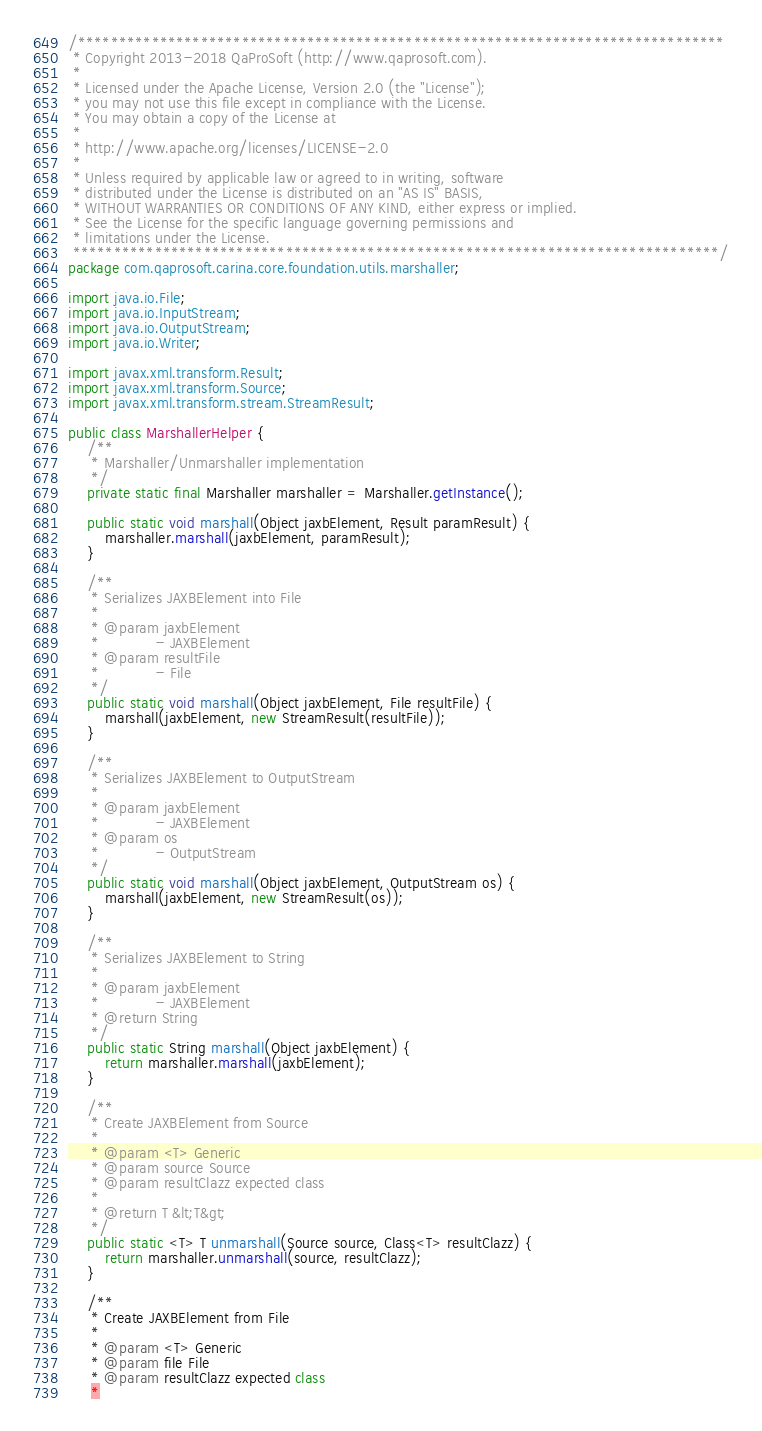Convert code to text. <code><loc_0><loc_0><loc_500><loc_500><_Java_>/*******************************************************************************
 * Copyright 2013-2018 QaProSoft (http://www.qaprosoft.com).
 *
 * Licensed under the Apache License, Version 2.0 (the "License");
 * you may not use this file except in compliance with the License.
 * You may obtain a copy of the License at
 *
 * http://www.apache.org/licenses/LICENSE-2.0
 *
 * Unless required by applicable law or agreed to in writing, software
 * distributed under the License is distributed on an "AS IS" BASIS,
 * WITHOUT WARRANTIES OR CONDITIONS OF ANY KIND, either express or implied.
 * See the License for the specific language governing permissions and
 * limitations under the License.
 *******************************************************************************/
package com.qaprosoft.carina.core.foundation.utils.marshaller;

import java.io.File;
import java.io.InputStream;
import java.io.OutputStream;
import java.io.Writer;

import javax.xml.transform.Result;
import javax.xml.transform.Source;
import javax.xml.transform.stream.StreamResult;

public class MarshallerHelper {
    /**
     * Marshaller/Unmarshaller implementation
     */
    private static final Marshaller marshaller = Marshaller.getInstance();

    public static void marshall(Object jaxbElement, Result paramResult) {
        marshaller.marshall(jaxbElement, paramResult);
    }

    /**
     * Serializes JAXBElement into File
     * 
     * @param jaxbElement
     *            - JAXBElement
     * @param resultFile
     *            - File
     */
    public static void marshall(Object jaxbElement, File resultFile) {
        marshall(jaxbElement, new StreamResult(resultFile));
    }

    /**
     * Serializes JAXBElement to OutputStream
     * 
     * @param jaxbElement
     *            - JAXBElement
     * @param os
     *            - OutputStream
     */
    public static void marshall(Object jaxbElement, OutputStream os) {
        marshall(jaxbElement, new StreamResult(os));
    }

    /**
     * Serializes JAXBElement to String
     * 
     * @param jaxbElement
     *            - JAXBElement
     * @return String
     */
    public static String marshall(Object jaxbElement) {
        return marshaller.marshall(jaxbElement);
    }

    /**
     * Create JAXBElement from Source
     * 
     * @param <T> Generic
     * @param source Source
     * @param resultClazz expected class
     * 
     * @return T &lt;T&gt;
     */
    public static <T> T unmarshall(Source source, Class<T> resultClazz) {
        return marshaller.unmarshall(source, resultClazz);
    }

    /**
     * Create JAXBElement from File
     * 
     * @param <T> Generic
     * @param file File
     * @param resultClazz expected class
     * </code> 